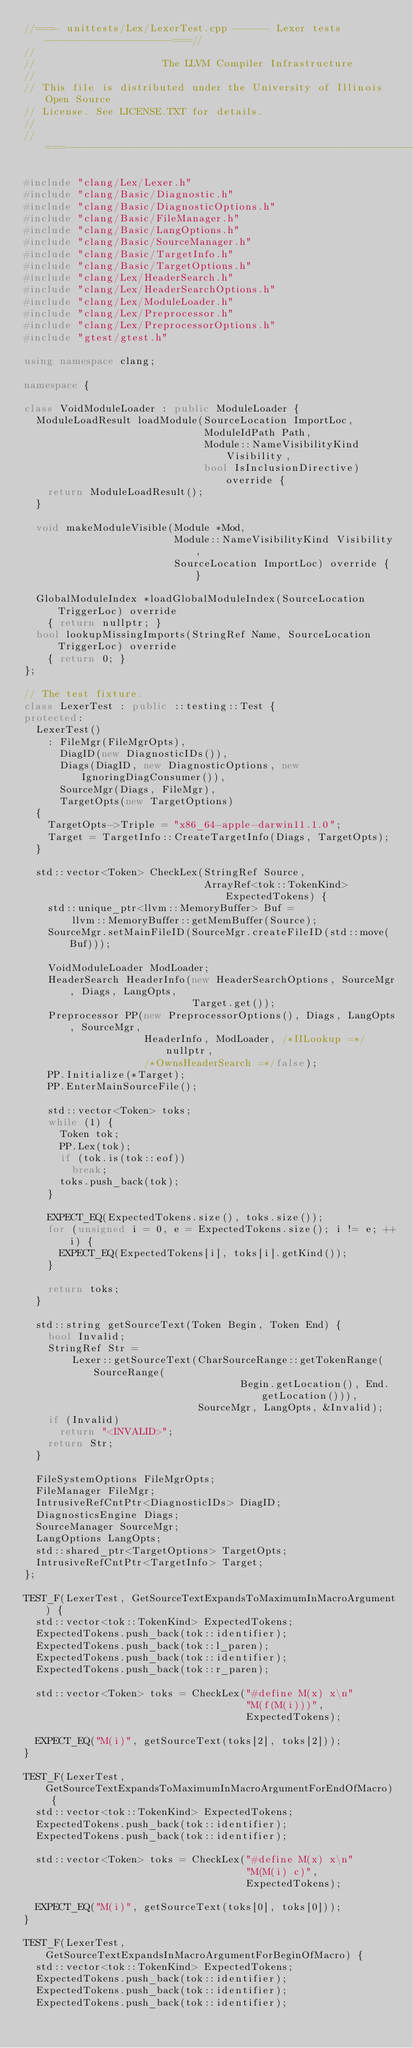Convert code to text. <code><loc_0><loc_0><loc_500><loc_500><_C++_>//===- unittests/Lex/LexerTest.cpp ------ Lexer tests ---------------------===//
//
//                     The LLVM Compiler Infrastructure
//
// This file is distributed under the University of Illinois Open Source
// License. See LICENSE.TXT for details.
//
//===----------------------------------------------------------------------===//

#include "clang/Lex/Lexer.h"
#include "clang/Basic/Diagnostic.h"
#include "clang/Basic/DiagnosticOptions.h"
#include "clang/Basic/FileManager.h"
#include "clang/Basic/LangOptions.h"
#include "clang/Basic/SourceManager.h"
#include "clang/Basic/TargetInfo.h"
#include "clang/Basic/TargetOptions.h"
#include "clang/Lex/HeaderSearch.h"
#include "clang/Lex/HeaderSearchOptions.h"
#include "clang/Lex/ModuleLoader.h"
#include "clang/Lex/Preprocessor.h"
#include "clang/Lex/PreprocessorOptions.h"
#include "gtest/gtest.h"

using namespace clang;

namespace {

class VoidModuleLoader : public ModuleLoader {
  ModuleLoadResult loadModule(SourceLocation ImportLoc, 
                              ModuleIdPath Path,
                              Module::NameVisibilityKind Visibility,
                              bool IsInclusionDirective) override {
    return ModuleLoadResult();
  }

  void makeModuleVisible(Module *Mod,
                         Module::NameVisibilityKind Visibility,
                         SourceLocation ImportLoc) override { }

  GlobalModuleIndex *loadGlobalModuleIndex(SourceLocation TriggerLoc) override
    { return nullptr; }
  bool lookupMissingImports(StringRef Name, SourceLocation TriggerLoc) override
    { return 0; }
};

// The test fixture.
class LexerTest : public ::testing::Test {
protected:
  LexerTest()
    : FileMgr(FileMgrOpts),
      DiagID(new DiagnosticIDs()),
      Diags(DiagID, new DiagnosticOptions, new IgnoringDiagConsumer()),
      SourceMgr(Diags, FileMgr),
      TargetOpts(new TargetOptions) 
  {
    TargetOpts->Triple = "x86_64-apple-darwin11.1.0";
    Target = TargetInfo::CreateTargetInfo(Diags, TargetOpts);
  }

  std::vector<Token> CheckLex(StringRef Source,
                              ArrayRef<tok::TokenKind> ExpectedTokens) {
    std::unique_ptr<llvm::MemoryBuffer> Buf =
        llvm::MemoryBuffer::getMemBuffer(Source);
    SourceMgr.setMainFileID(SourceMgr.createFileID(std::move(Buf)));

    VoidModuleLoader ModLoader;
    HeaderSearch HeaderInfo(new HeaderSearchOptions, SourceMgr, Diags, LangOpts,
                            Target.get());
    Preprocessor PP(new PreprocessorOptions(), Diags, LangOpts, SourceMgr,
                    HeaderInfo, ModLoader, /*IILookup =*/nullptr,
                    /*OwnsHeaderSearch =*/false);
    PP.Initialize(*Target);
    PP.EnterMainSourceFile();

    std::vector<Token> toks;
    while (1) {
      Token tok;
      PP.Lex(tok);
      if (tok.is(tok::eof))
        break;
      toks.push_back(tok);
    }

    EXPECT_EQ(ExpectedTokens.size(), toks.size());
    for (unsigned i = 0, e = ExpectedTokens.size(); i != e; ++i) {
      EXPECT_EQ(ExpectedTokens[i], toks[i].getKind());
    }

    return toks;
  }

  std::string getSourceText(Token Begin, Token End) {
    bool Invalid;
    StringRef Str =
        Lexer::getSourceText(CharSourceRange::getTokenRange(SourceRange(
                                    Begin.getLocation(), End.getLocation())),
                             SourceMgr, LangOpts, &Invalid);
    if (Invalid)
      return "<INVALID>";
    return Str;
  }

  FileSystemOptions FileMgrOpts;
  FileManager FileMgr;
  IntrusiveRefCntPtr<DiagnosticIDs> DiagID;
  DiagnosticsEngine Diags;
  SourceManager SourceMgr;
  LangOptions LangOpts;
  std::shared_ptr<TargetOptions> TargetOpts;
  IntrusiveRefCntPtr<TargetInfo> Target;
};

TEST_F(LexerTest, GetSourceTextExpandsToMaximumInMacroArgument) {
  std::vector<tok::TokenKind> ExpectedTokens;
  ExpectedTokens.push_back(tok::identifier);
  ExpectedTokens.push_back(tok::l_paren);
  ExpectedTokens.push_back(tok::identifier);
  ExpectedTokens.push_back(tok::r_paren);

  std::vector<Token> toks = CheckLex("#define M(x) x\n"
                                     "M(f(M(i)))",
                                     ExpectedTokens);

  EXPECT_EQ("M(i)", getSourceText(toks[2], toks[2]));
}

TEST_F(LexerTest, GetSourceTextExpandsToMaximumInMacroArgumentForEndOfMacro) {
  std::vector<tok::TokenKind> ExpectedTokens;
  ExpectedTokens.push_back(tok::identifier);
  ExpectedTokens.push_back(tok::identifier);

  std::vector<Token> toks = CheckLex("#define M(x) x\n"
                                     "M(M(i) c)",
                                     ExpectedTokens);

  EXPECT_EQ("M(i)", getSourceText(toks[0], toks[0]));
}

TEST_F(LexerTest, GetSourceTextExpandsInMacroArgumentForBeginOfMacro) {
  std::vector<tok::TokenKind> ExpectedTokens;
  ExpectedTokens.push_back(tok::identifier);
  ExpectedTokens.push_back(tok::identifier);
  ExpectedTokens.push_back(tok::identifier);
</code> 